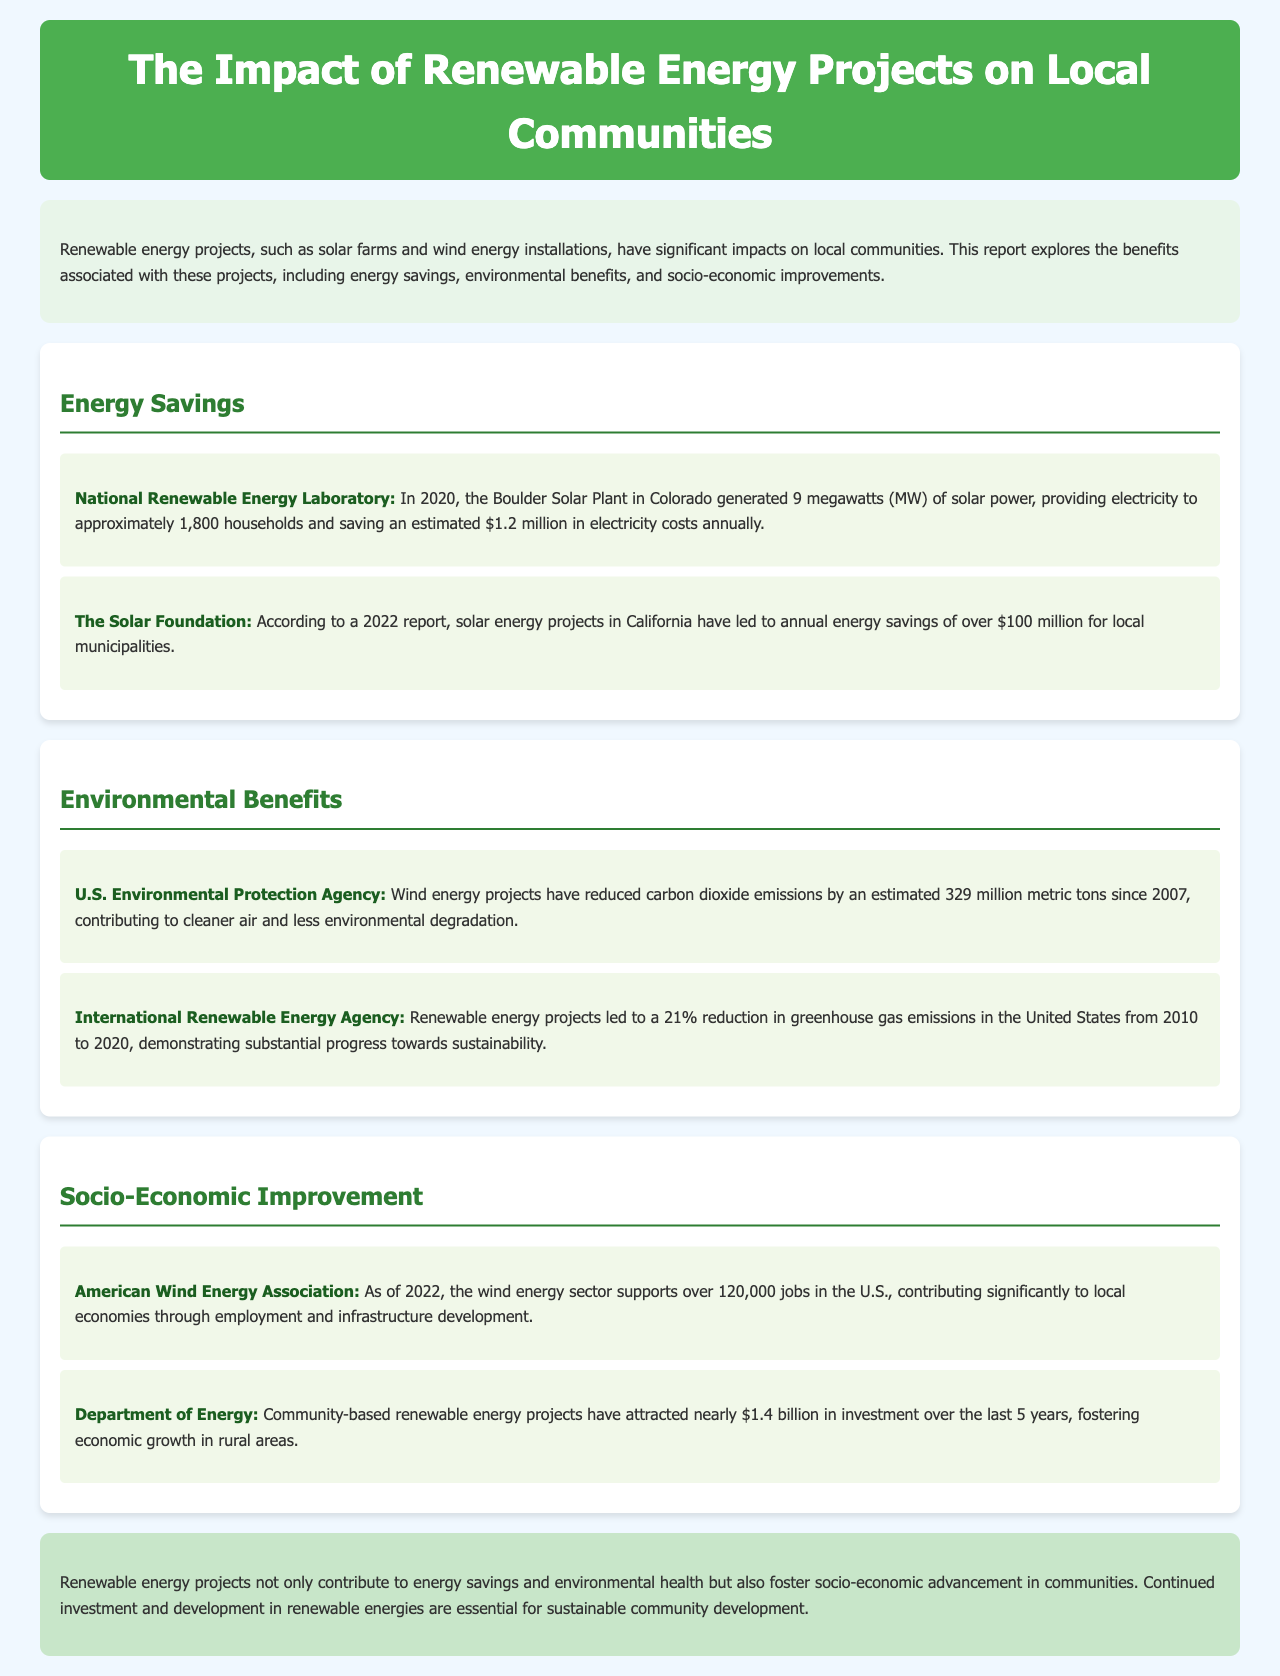what is the electricity generation capacity of the Boulder Solar Plant? The Boulder Solar Plant in Colorado generated 9 megawatts (MW) of solar power.
Answer: 9 megawatts how much money did solar energy projects in California save local municipalities annually? According to a 2022 report, solar energy projects in California have led to annual energy savings of over $100 million for local municipalities.
Answer: over $100 million how many metric tons of carbon dioxide emissions have wind energy projects reduced since 2007? Wind energy projects have reduced carbon dioxide emissions by an estimated 329 million metric tons since 2007.
Answer: 329 million metric tons what was the percentage reduction in greenhouse gas emissions in the United States from 2010 to 2020? Renewable energy projects led to a 21% reduction in greenhouse gas emissions in the United States from 2010 to 2020.
Answer: 21% how many jobs does the wind energy sector support in the U.S. as of 2022? As of 2022, the wind energy sector supports over 120,000 jobs in the U.S.
Answer: over 120,000 jobs what is the total investment attracted by community-based renewable energy projects over the last 5 years? Community-based renewable energy projects have attracted nearly $1.4 billion in investment over the last 5 years.
Answer: nearly $1.4 billion what is the primary focus of the report? The report explores the benefits associated with renewable energy projects, including energy savings, environmental benefits, and socio-economic improvements.
Answer: benefits of renewable energy projects who provided the statistic on annual energy savings from solar energy projects in California? The statistic on annual energy savings from solar energy projects in California was provided by The Solar Foundation.
Answer: The Solar Foundation which organization reported on the reduction of carbon dioxide emissions by wind energy projects? The U.S. Environmental Protection Agency reported on the reduction of carbon dioxide emissions by wind energy projects.
Answer: U.S. Environmental Protection Agency 